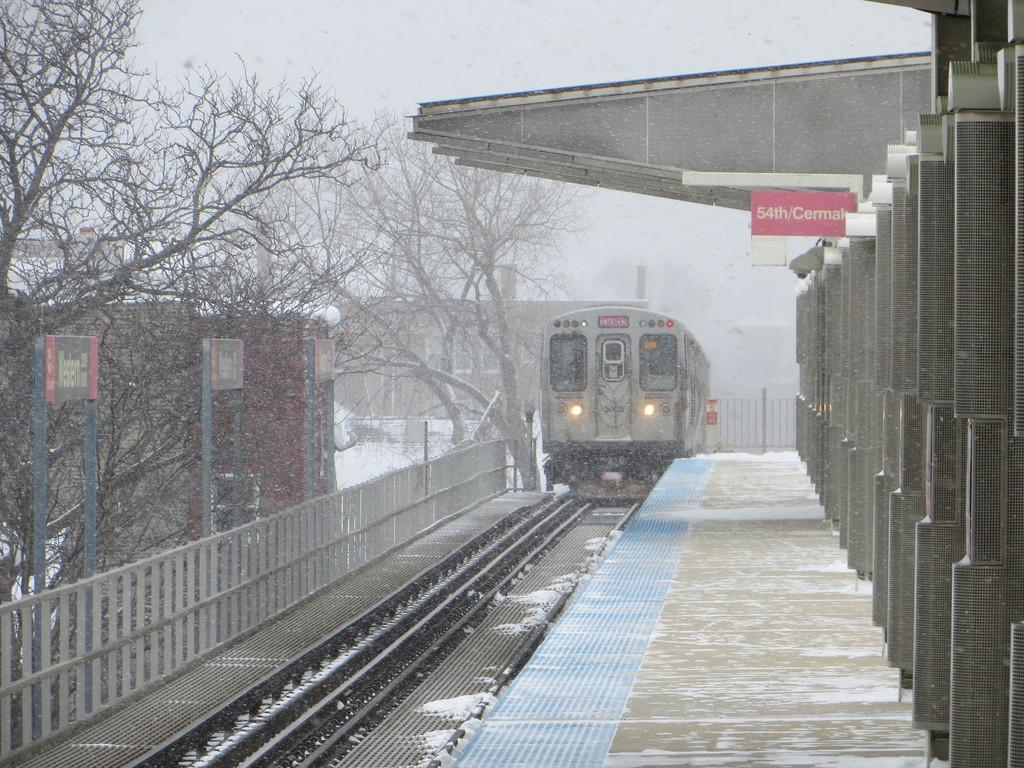<image>
Relay a brief, clear account of the picture shown. A sign for 54th/Cermak hangs over a train platform. 